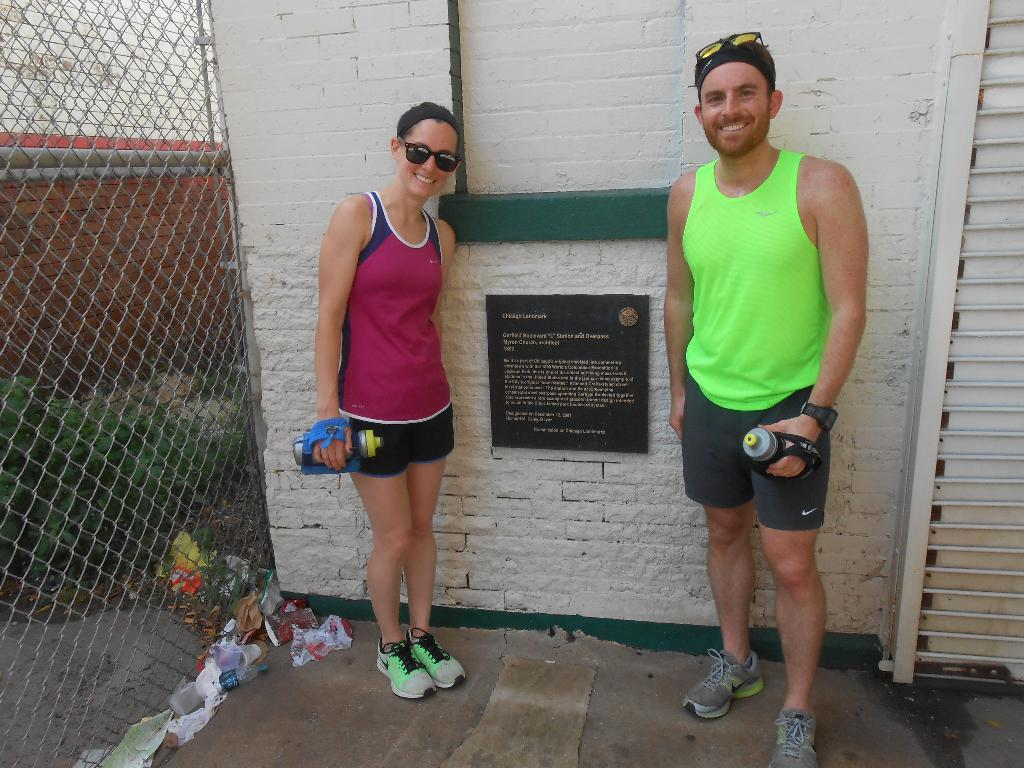Who can be seen in the foreground of the image? There is a woman and a man standing in the foreground of the image. What are they standing near? They are near a notice board. What type of fencing is visible in the image? There is net fencing in the image. What other elements can be seen in the image? Plants and waste materials are visible in the image. Can you see a ring on the woman's finger in the image? There is no ring visible on the woman's finger in the image. What type of window is present in the image? There is no window present in the image. 